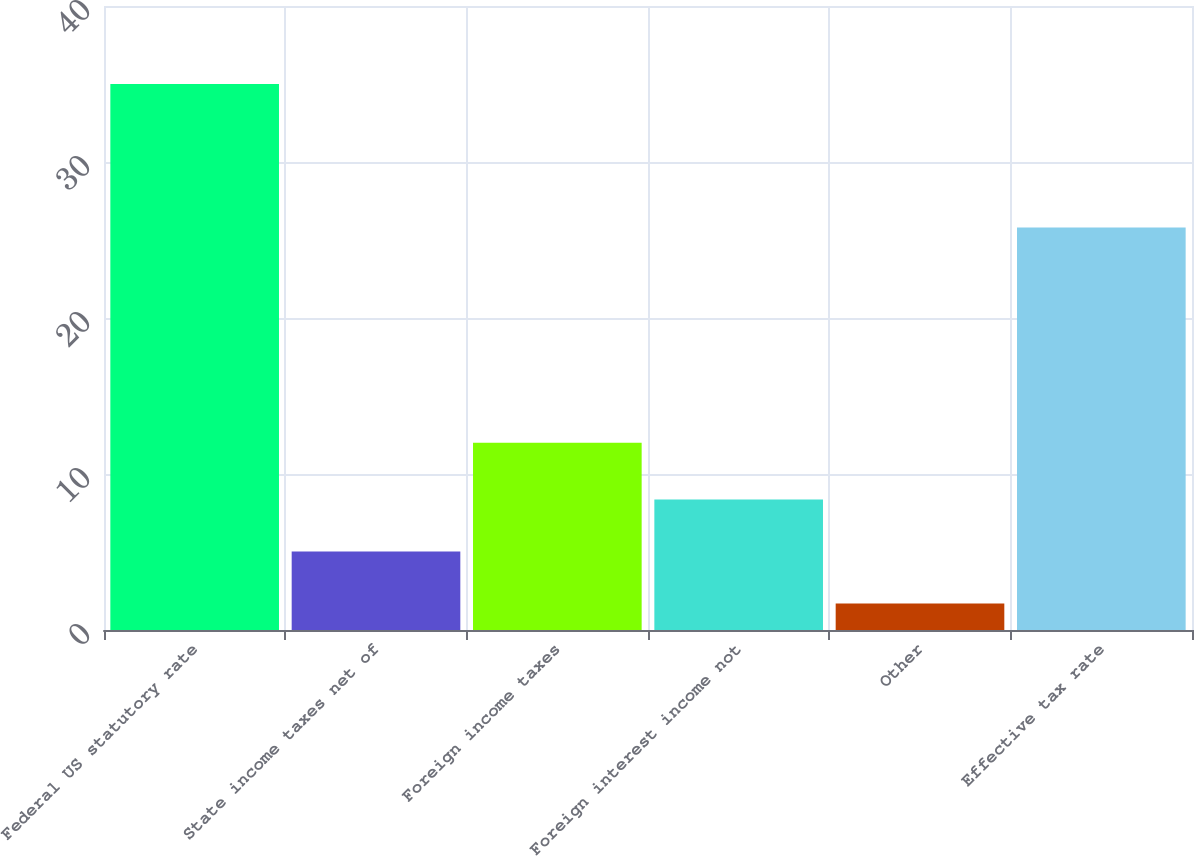Convert chart to OTSL. <chart><loc_0><loc_0><loc_500><loc_500><bar_chart><fcel>Federal US statutory rate<fcel>State income taxes net of<fcel>Foreign income taxes<fcel>Foreign interest income not<fcel>Other<fcel>Effective tax rate<nl><fcel>35<fcel>5.03<fcel>12<fcel>8.36<fcel>1.7<fcel>25.8<nl></chart> 